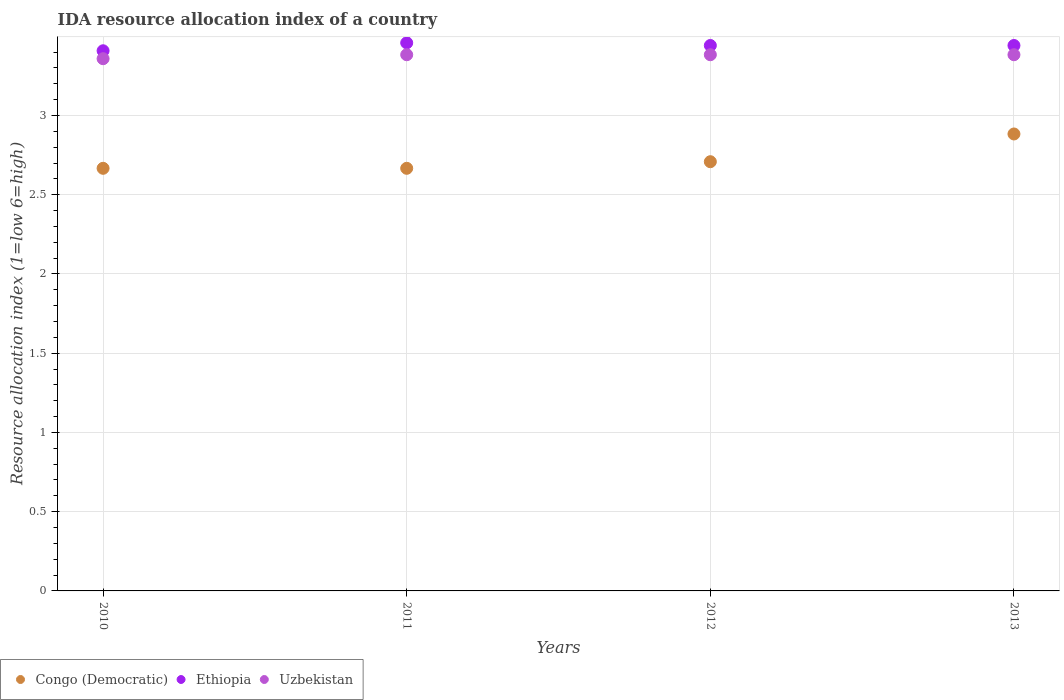How many different coloured dotlines are there?
Give a very brief answer. 3. What is the IDA resource allocation index in Uzbekistan in 2010?
Provide a short and direct response. 3.36. Across all years, what is the maximum IDA resource allocation index in Congo (Democratic)?
Provide a succinct answer. 2.88. Across all years, what is the minimum IDA resource allocation index in Uzbekistan?
Your answer should be very brief. 3.36. In which year was the IDA resource allocation index in Ethiopia maximum?
Your response must be concise. 2011. In which year was the IDA resource allocation index in Ethiopia minimum?
Keep it short and to the point. 2010. What is the total IDA resource allocation index in Congo (Democratic) in the graph?
Provide a short and direct response. 10.93. What is the difference between the IDA resource allocation index in Congo (Democratic) in 2010 and that in 2013?
Provide a succinct answer. -0.22. What is the difference between the IDA resource allocation index in Uzbekistan in 2013 and the IDA resource allocation index in Ethiopia in 2012?
Offer a terse response. -0.06. What is the average IDA resource allocation index in Uzbekistan per year?
Offer a terse response. 3.38. In the year 2011, what is the difference between the IDA resource allocation index in Ethiopia and IDA resource allocation index in Congo (Democratic)?
Offer a very short reply. 0.79. In how many years, is the IDA resource allocation index in Congo (Democratic) greater than 2.7?
Offer a terse response. 2. What is the ratio of the IDA resource allocation index in Ethiopia in 2010 to that in 2012?
Your response must be concise. 0.99. Is the IDA resource allocation index in Ethiopia in 2011 less than that in 2013?
Offer a very short reply. No. Is the difference between the IDA resource allocation index in Ethiopia in 2011 and 2013 greater than the difference between the IDA resource allocation index in Congo (Democratic) in 2011 and 2013?
Keep it short and to the point. Yes. What is the difference between the highest and the second highest IDA resource allocation index in Uzbekistan?
Provide a succinct answer. 0. What is the difference between the highest and the lowest IDA resource allocation index in Uzbekistan?
Keep it short and to the point. 0.03. Is the sum of the IDA resource allocation index in Congo (Democratic) in 2011 and 2013 greater than the maximum IDA resource allocation index in Ethiopia across all years?
Offer a terse response. Yes. Does the IDA resource allocation index in Congo (Democratic) monotonically increase over the years?
Your answer should be very brief. No. How many years are there in the graph?
Your answer should be compact. 4. What is the difference between two consecutive major ticks on the Y-axis?
Your answer should be compact. 0.5. Are the values on the major ticks of Y-axis written in scientific E-notation?
Provide a succinct answer. No. Where does the legend appear in the graph?
Your answer should be very brief. Bottom left. How many legend labels are there?
Make the answer very short. 3. What is the title of the graph?
Provide a succinct answer. IDA resource allocation index of a country. What is the label or title of the X-axis?
Your answer should be compact. Years. What is the label or title of the Y-axis?
Keep it short and to the point. Resource allocation index (1=low 6=high). What is the Resource allocation index (1=low 6=high) of Congo (Democratic) in 2010?
Your response must be concise. 2.67. What is the Resource allocation index (1=low 6=high) of Ethiopia in 2010?
Offer a very short reply. 3.41. What is the Resource allocation index (1=low 6=high) of Uzbekistan in 2010?
Your answer should be very brief. 3.36. What is the Resource allocation index (1=low 6=high) of Congo (Democratic) in 2011?
Give a very brief answer. 2.67. What is the Resource allocation index (1=low 6=high) of Ethiopia in 2011?
Make the answer very short. 3.46. What is the Resource allocation index (1=low 6=high) in Uzbekistan in 2011?
Your answer should be compact. 3.38. What is the Resource allocation index (1=low 6=high) of Congo (Democratic) in 2012?
Make the answer very short. 2.71. What is the Resource allocation index (1=low 6=high) of Ethiopia in 2012?
Your response must be concise. 3.44. What is the Resource allocation index (1=low 6=high) in Uzbekistan in 2012?
Provide a succinct answer. 3.38. What is the Resource allocation index (1=low 6=high) of Congo (Democratic) in 2013?
Give a very brief answer. 2.88. What is the Resource allocation index (1=low 6=high) of Ethiopia in 2013?
Provide a short and direct response. 3.44. What is the Resource allocation index (1=low 6=high) in Uzbekistan in 2013?
Your answer should be compact. 3.38. Across all years, what is the maximum Resource allocation index (1=low 6=high) of Congo (Democratic)?
Ensure brevity in your answer.  2.88. Across all years, what is the maximum Resource allocation index (1=low 6=high) of Ethiopia?
Give a very brief answer. 3.46. Across all years, what is the maximum Resource allocation index (1=low 6=high) in Uzbekistan?
Keep it short and to the point. 3.38. Across all years, what is the minimum Resource allocation index (1=low 6=high) of Congo (Democratic)?
Your response must be concise. 2.67. Across all years, what is the minimum Resource allocation index (1=low 6=high) of Ethiopia?
Offer a very short reply. 3.41. Across all years, what is the minimum Resource allocation index (1=low 6=high) in Uzbekistan?
Your answer should be very brief. 3.36. What is the total Resource allocation index (1=low 6=high) of Congo (Democratic) in the graph?
Provide a short and direct response. 10.93. What is the total Resource allocation index (1=low 6=high) in Ethiopia in the graph?
Provide a short and direct response. 13.75. What is the total Resource allocation index (1=low 6=high) of Uzbekistan in the graph?
Your response must be concise. 13.51. What is the difference between the Resource allocation index (1=low 6=high) in Congo (Democratic) in 2010 and that in 2011?
Offer a very short reply. 0. What is the difference between the Resource allocation index (1=low 6=high) in Ethiopia in 2010 and that in 2011?
Offer a very short reply. -0.05. What is the difference between the Resource allocation index (1=low 6=high) of Uzbekistan in 2010 and that in 2011?
Keep it short and to the point. -0.03. What is the difference between the Resource allocation index (1=low 6=high) of Congo (Democratic) in 2010 and that in 2012?
Offer a very short reply. -0.04. What is the difference between the Resource allocation index (1=low 6=high) of Ethiopia in 2010 and that in 2012?
Give a very brief answer. -0.03. What is the difference between the Resource allocation index (1=low 6=high) of Uzbekistan in 2010 and that in 2012?
Keep it short and to the point. -0.03. What is the difference between the Resource allocation index (1=low 6=high) in Congo (Democratic) in 2010 and that in 2013?
Your answer should be compact. -0.22. What is the difference between the Resource allocation index (1=low 6=high) in Ethiopia in 2010 and that in 2013?
Ensure brevity in your answer.  -0.03. What is the difference between the Resource allocation index (1=low 6=high) of Uzbekistan in 2010 and that in 2013?
Your answer should be compact. -0.03. What is the difference between the Resource allocation index (1=low 6=high) of Congo (Democratic) in 2011 and that in 2012?
Provide a succinct answer. -0.04. What is the difference between the Resource allocation index (1=low 6=high) of Ethiopia in 2011 and that in 2012?
Offer a terse response. 0.02. What is the difference between the Resource allocation index (1=low 6=high) of Uzbekistan in 2011 and that in 2012?
Ensure brevity in your answer.  0. What is the difference between the Resource allocation index (1=low 6=high) of Congo (Democratic) in 2011 and that in 2013?
Your answer should be compact. -0.22. What is the difference between the Resource allocation index (1=low 6=high) in Ethiopia in 2011 and that in 2013?
Offer a very short reply. 0.02. What is the difference between the Resource allocation index (1=low 6=high) of Congo (Democratic) in 2012 and that in 2013?
Offer a terse response. -0.17. What is the difference between the Resource allocation index (1=low 6=high) of Uzbekistan in 2012 and that in 2013?
Your response must be concise. 0. What is the difference between the Resource allocation index (1=low 6=high) in Congo (Democratic) in 2010 and the Resource allocation index (1=low 6=high) in Ethiopia in 2011?
Your answer should be very brief. -0.79. What is the difference between the Resource allocation index (1=low 6=high) of Congo (Democratic) in 2010 and the Resource allocation index (1=low 6=high) of Uzbekistan in 2011?
Your answer should be compact. -0.72. What is the difference between the Resource allocation index (1=low 6=high) of Ethiopia in 2010 and the Resource allocation index (1=low 6=high) of Uzbekistan in 2011?
Your answer should be very brief. 0.03. What is the difference between the Resource allocation index (1=low 6=high) of Congo (Democratic) in 2010 and the Resource allocation index (1=low 6=high) of Ethiopia in 2012?
Provide a short and direct response. -0.78. What is the difference between the Resource allocation index (1=low 6=high) of Congo (Democratic) in 2010 and the Resource allocation index (1=low 6=high) of Uzbekistan in 2012?
Make the answer very short. -0.72. What is the difference between the Resource allocation index (1=low 6=high) in Ethiopia in 2010 and the Resource allocation index (1=low 6=high) in Uzbekistan in 2012?
Give a very brief answer. 0.03. What is the difference between the Resource allocation index (1=low 6=high) of Congo (Democratic) in 2010 and the Resource allocation index (1=low 6=high) of Ethiopia in 2013?
Your answer should be very brief. -0.78. What is the difference between the Resource allocation index (1=low 6=high) of Congo (Democratic) in 2010 and the Resource allocation index (1=low 6=high) of Uzbekistan in 2013?
Your response must be concise. -0.72. What is the difference between the Resource allocation index (1=low 6=high) of Ethiopia in 2010 and the Resource allocation index (1=low 6=high) of Uzbekistan in 2013?
Your answer should be compact. 0.03. What is the difference between the Resource allocation index (1=low 6=high) of Congo (Democratic) in 2011 and the Resource allocation index (1=low 6=high) of Ethiopia in 2012?
Offer a terse response. -0.78. What is the difference between the Resource allocation index (1=low 6=high) in Congo (Democratic) in 2011 and the Resource allocation index (1=low 6=high) in Uzbekistan in 2012?
Ensure brevity in your answer.  -0.72. What is the difference between the Resource allocation index (1=low 6=high) in Ethiopia in 2011 and the Resource allocation index (1=low 6=high) in Uzbekistan in 2012?
Your answer should be very brief. 0.07. What is the difference between the Resource allocation index (1=low 6=high) of Congo (Democratic) in 2011 and the Resource allocation index (1=low 6=high) of Ethiopia in 2013?
Provide a short and direct response. -0.78. What is the difference between the Resource allocation index (1=low 6=high) in Congo (Democratic) in 2011 and the Resource allocation index (1=low 6=high) in Uzbekistan in 2013?
Keep it short and to the point. -0.72. What is the difference between the Resource allocation index (1=low 6=high) in Ethiopia in 2011 and the Resource allocation index (1=low 6=high) in Uzbekistan in 2013?
Provide a short and direct response. 0.07. What is the difference between the Resource allocation index (1=low 6=high) of Congo (Democratic) in 2012 and the Resource allocation index (1=low 6=high) of Ethiopia in 2013?
Your response must be concise. -0.73. What is the difference between the Resource allocation index (1=low 6=high) in Congo (Democratic) in 2012 and the Resource allocation index (1=low 6=high) in Uzbekistan in 2013?
Provide a succinct answer. -0.68. What is the difference between the Resource allocation index (1=low 6=high) in Ethiopia in 2012 and the Resource allocation index (1=low 6=high) in Uzbekistan in 2013?
Your answer should be compact. 0.06. What is the average Resource allocation index (1=low 6=high) of Congo (Democratic) per year?
Offer a very short reply. 2.73. What is the average Resource allocation index (1=low 6=high) of Ethiopia per year?
Offer a very short reply. 3.44. What is the average Resource allocation index (1=low 6=high) of Uzbekistan per year?
Keep it short and to the point. 3.38. In the year 2010, what is the difference between the Resource allocation index (1=low 6=high) in Congo (Democratic) and Resource allocation index (1=low 6=high) in Ethiopia?
Ensure brevity in your answer.  -0.74. In the year 2010, what is the difference between the Resource allocation index (1=low 6=high) in Congo (Democratic) and Resource allocation index (1=low 6=high) in Uzbekistan?
Provide a short and direct response. -0.69. In the year 2011, what is the difference between the Resource allocation index (1=low 6=high) of Congo (Democratic) and Resource allocation index (1=low 6=high) of Ethiopia?
Keep it short and to the point. -0.79. In the year 2011, what is the difference between the Resource allocation index (1=low 6=high) in Congo (Democratic) and Resource allocation index (1=low 6=high) in Uzbekistan?
Keep it short and to the point. -0.72. In the year 2011, what is the difference between the Resource allocation index (1=low 6=high) of Ethiopia and Resource allocation index (1=low 6=high) of Uzbekistan?
Your answer should be compact. 0.07. In the year 2012, what is the difference between the Resource allocation index (1=low 6=high) of Congo (Democratic) and Resource allocation index (1=low 6=high) of Ethiopia?
Make the answer very short. -0.73. In the year 2012, what is the difference between the Resource allocation index (1=low 6=high) in Congo (Democratic) and Resource allocation index (1=low 6=high) in Uzbekistan?
Offer a very short reply. -0.68. In the year 2012, what is the difference between the Resource allocation index (1=low 6=high) in Ethiopia and Resource allocation index (1=low 6=high) in Uzbekistan?
Provide a short and direct response. 0.06. In the year 2013, what is the difference between the Resource allocation index (1=low 6=high) in Congo (Democratic) and Resource allocation index (1=low 6=high) in Ethiopia?
Ensure brevity in your answer.  -0.56. In the year 2013, what is the difference between the Resource allocation index (1=low 6=high) of Ethiopia and Resource allocation index (1=low 6=high) of Uzbekistan?
Your answer should be compact. 0.06. What is the ratio of the Resource allocation index (1=low 6=high) of Ethiopia in 2010 to that in 2011?
Your response must be concise. 0.99. What is the ratio of the Resource allocation index (1=low 6=high) in Congo (Democratic) in 2010 to that in 2012?
Make the answer very short. 0.98. What is the ratio of the Resource allocation index (1=low 6=high) of Ethiopia in 2010 to that in 2012?
Provide a succinct answer. 0.99. What is the ratio of the Resource allocation index (1=low 6=high) of Congo (Democratic) in 2010 to that in 2013?
Make the answer very short. 0.92. What is the ratio of the Resource allocation index (1=low 6=high) of Ethiopia in 2010 to that in 2013?
Provide a short and direct response. 0.99. What is the ratio of the Resource allocation index (1=low 6=high) in Uzbekistan in 2010 to that in 2013?
Make the answer very short. 0.99. What is the ratio of the Resource allocation index (1=low 6=high) in Congo (Democratic) in 2011 to that in 2012?
Offer a very short reply. 0.98. What is the ratio of the Resource allocation index (1=low 6=high) of Ethiopia in 2011 to that in 2012?
Make the answer very short. 1. What is the ratio of the Resource allocation index (1=low 6=high) of Congo (Democratic) in 2011 to that in 2013?
Keep it short and to the point. 0.92. What is the ratio of the Resource allocation index (1=low 6=high) in Congo (Democratic) in 2012 to that in 2013?
Give a very brief answer. 0.94. What is the difference between the highest and the second highest Resource allocation index (1=low 6=high) of Congo (Democratic)?
Keep it short and to the point. 0.17. What is the difference between the highest and the second highest Resource allocation index (1=low 6=high) in Ethiopia?
Your answer should be compact. 0.02. What is the difference between the highest and the second highest Resource allocation index (1=low 6=high) of Uzbekistan?
Provide a succinct answer. 0. What is the difference between the highest and the lowest Resource allocation index (1=low 6=high) in Congo (Democratic)?
Provide a succinct answer. 0.22. What is the difference between the highest and the lowest Resource allocation index (1=low 6=high) of Ethiopia?
Keep it short and to the point. 0.05. What is the difference between the highest and the lowest Resource allocation index (1=low 6=high) of Uzbekistan?
Provide a succinct answer. 0.03. 